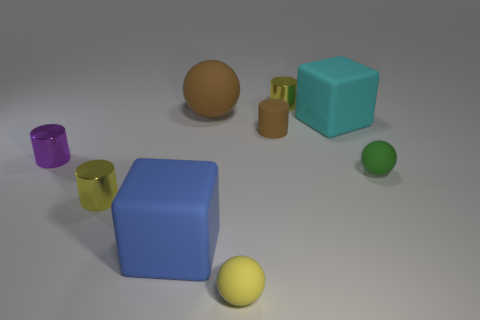There is a matte sphere that is the same color as the small rubber cylinder; what size is it?
Ensure brevity in your answer.  Large. Is the color of the matte cylinder the same as the large sphere?
Your response must be concise. Yes. Do the small rubber ball that is in front of the blue rubber thing and the big ball have the same color?
Provide a short and direct response. No. What number of small brown matte objects are in front of the green rubber thing?
Provide a short and direct response. 0. Are there more yellow spheres than brown things?
Your answer should be compact. No. There is a matte object that is both on the left side of the small brown matte cylinder and on the right side of the large brown matte sphere; what is its shape?
Keep it short and to the point. Sphere. Is there a large thing?
Give a very brief answer. Yes. There is another big thing that is the same shape as the big cyan matte thing; what is it made of?
Make the answer very short. Rubber. What shape is the blue matte thing behind the small rubber object in front of the yellow cylinder to the left of the brown sphere?
Keep it short and to the point. Cube. What material is the cylinder that is the same color as the big sphere?
Provide a short and direct response. Rubber. 